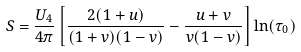<formula> <loc_0><loc_0><loc_500><loc_500>S = \frac { U _ { 4 } } { 4 \pi } \left [ \frac { 2 ( 1 + u ) } { ( 1 + v ) ( 1 - v ) } - \frac { u + v } { v ( 1 - v ) } \right ] \ln ( \tau _ { 0 } )</formula> 